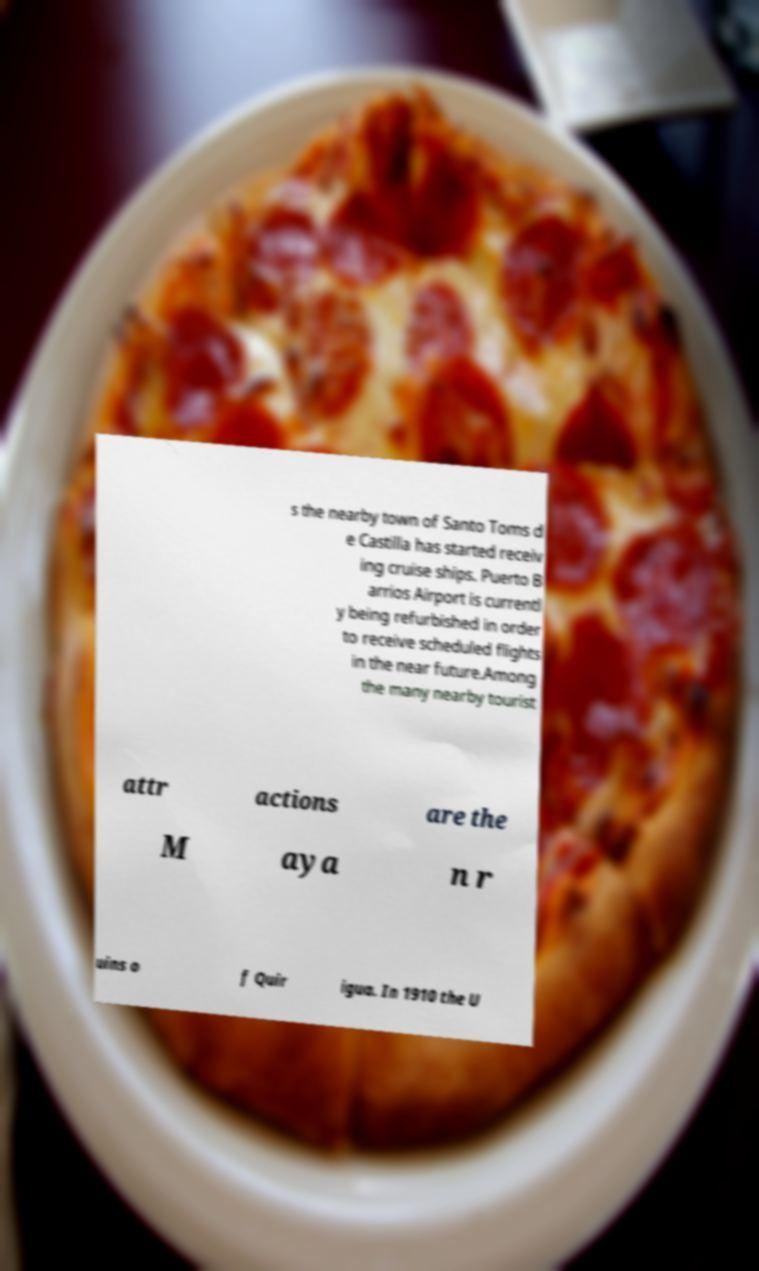What messages or text are displayed in this image? I need them in a readable, typed format. s the nearby town of Santo Toms d e Castilla has started receiv ing cruise ships. Puerto B arrios Airport is currentl y being refurbished in order to receive scheduled flights in the near future.Among the many nearby tourist attr actions are the M aya n r uins o f Quir igua. In 1910 the U 